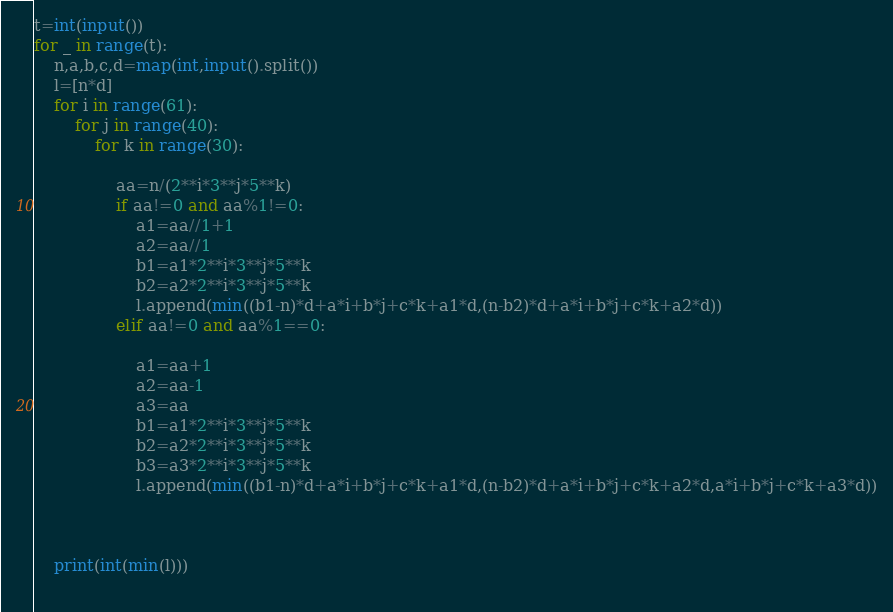Convert code to text. <code><loc_0><loc_0><loc_500><loc_500><_Python_>t=int(input())
for _ in range(t):
    n,a,b,c,d=map(int,input().split())
    l=[n*d]
    for i in range(61):
        for j in range(40):
            for k in range(30):
                
                aa=n/(2**i*3**j*5**k)
                if aa!=0 and aa%1!=0:
                    a1=aa//1+1
                    a2=aa//1
                    b1=a1*2**i*3**j*5**k
                    b2=a2*2**i*3**j*5**k
                    l.append(min((b1-n)*d+a*i+b*j+c*k+a1*d,(n-b2)*d+a*i+b*j+c*k+a2*d))
                elif aa!=0 and aa%1==0:
                    
                    a1=aa+1
                    a2=aa-1
                    a3=aa
                    b1=a1*2**i*3**j*5**k
                    b2=a2*2**i*3**j*5**k
                    b3=a3*2**i*3**j*5**k
                    l.append(min((b1-n)*d+a*i+b*j+c*k+a1*d,(n-b2)*d+a*i+b*j+c*k+a2*d,a*i+b*j+c*k+a3*d))
                    

    
    print(int(min(l)))
    </code> 